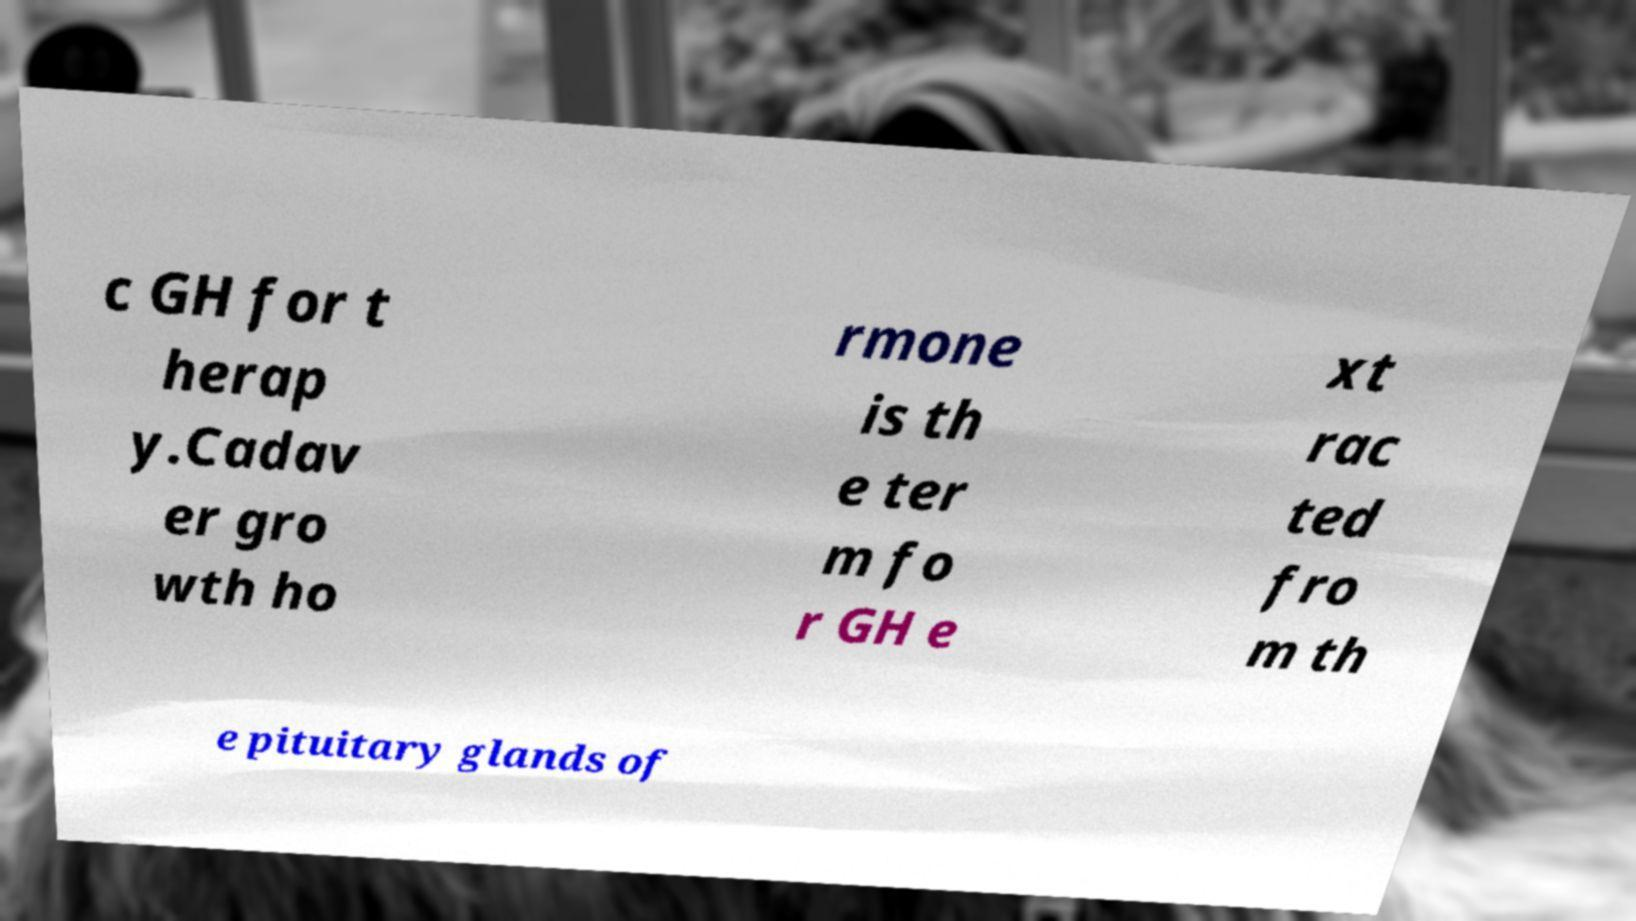For documentation purposes, I need the text within this image transcribed. Could you provide that? c GH for t herap y.Cadav er gro wth ho rmone is th e ter m fo r GH e xt rac ted fro m th e pituitary glands of 